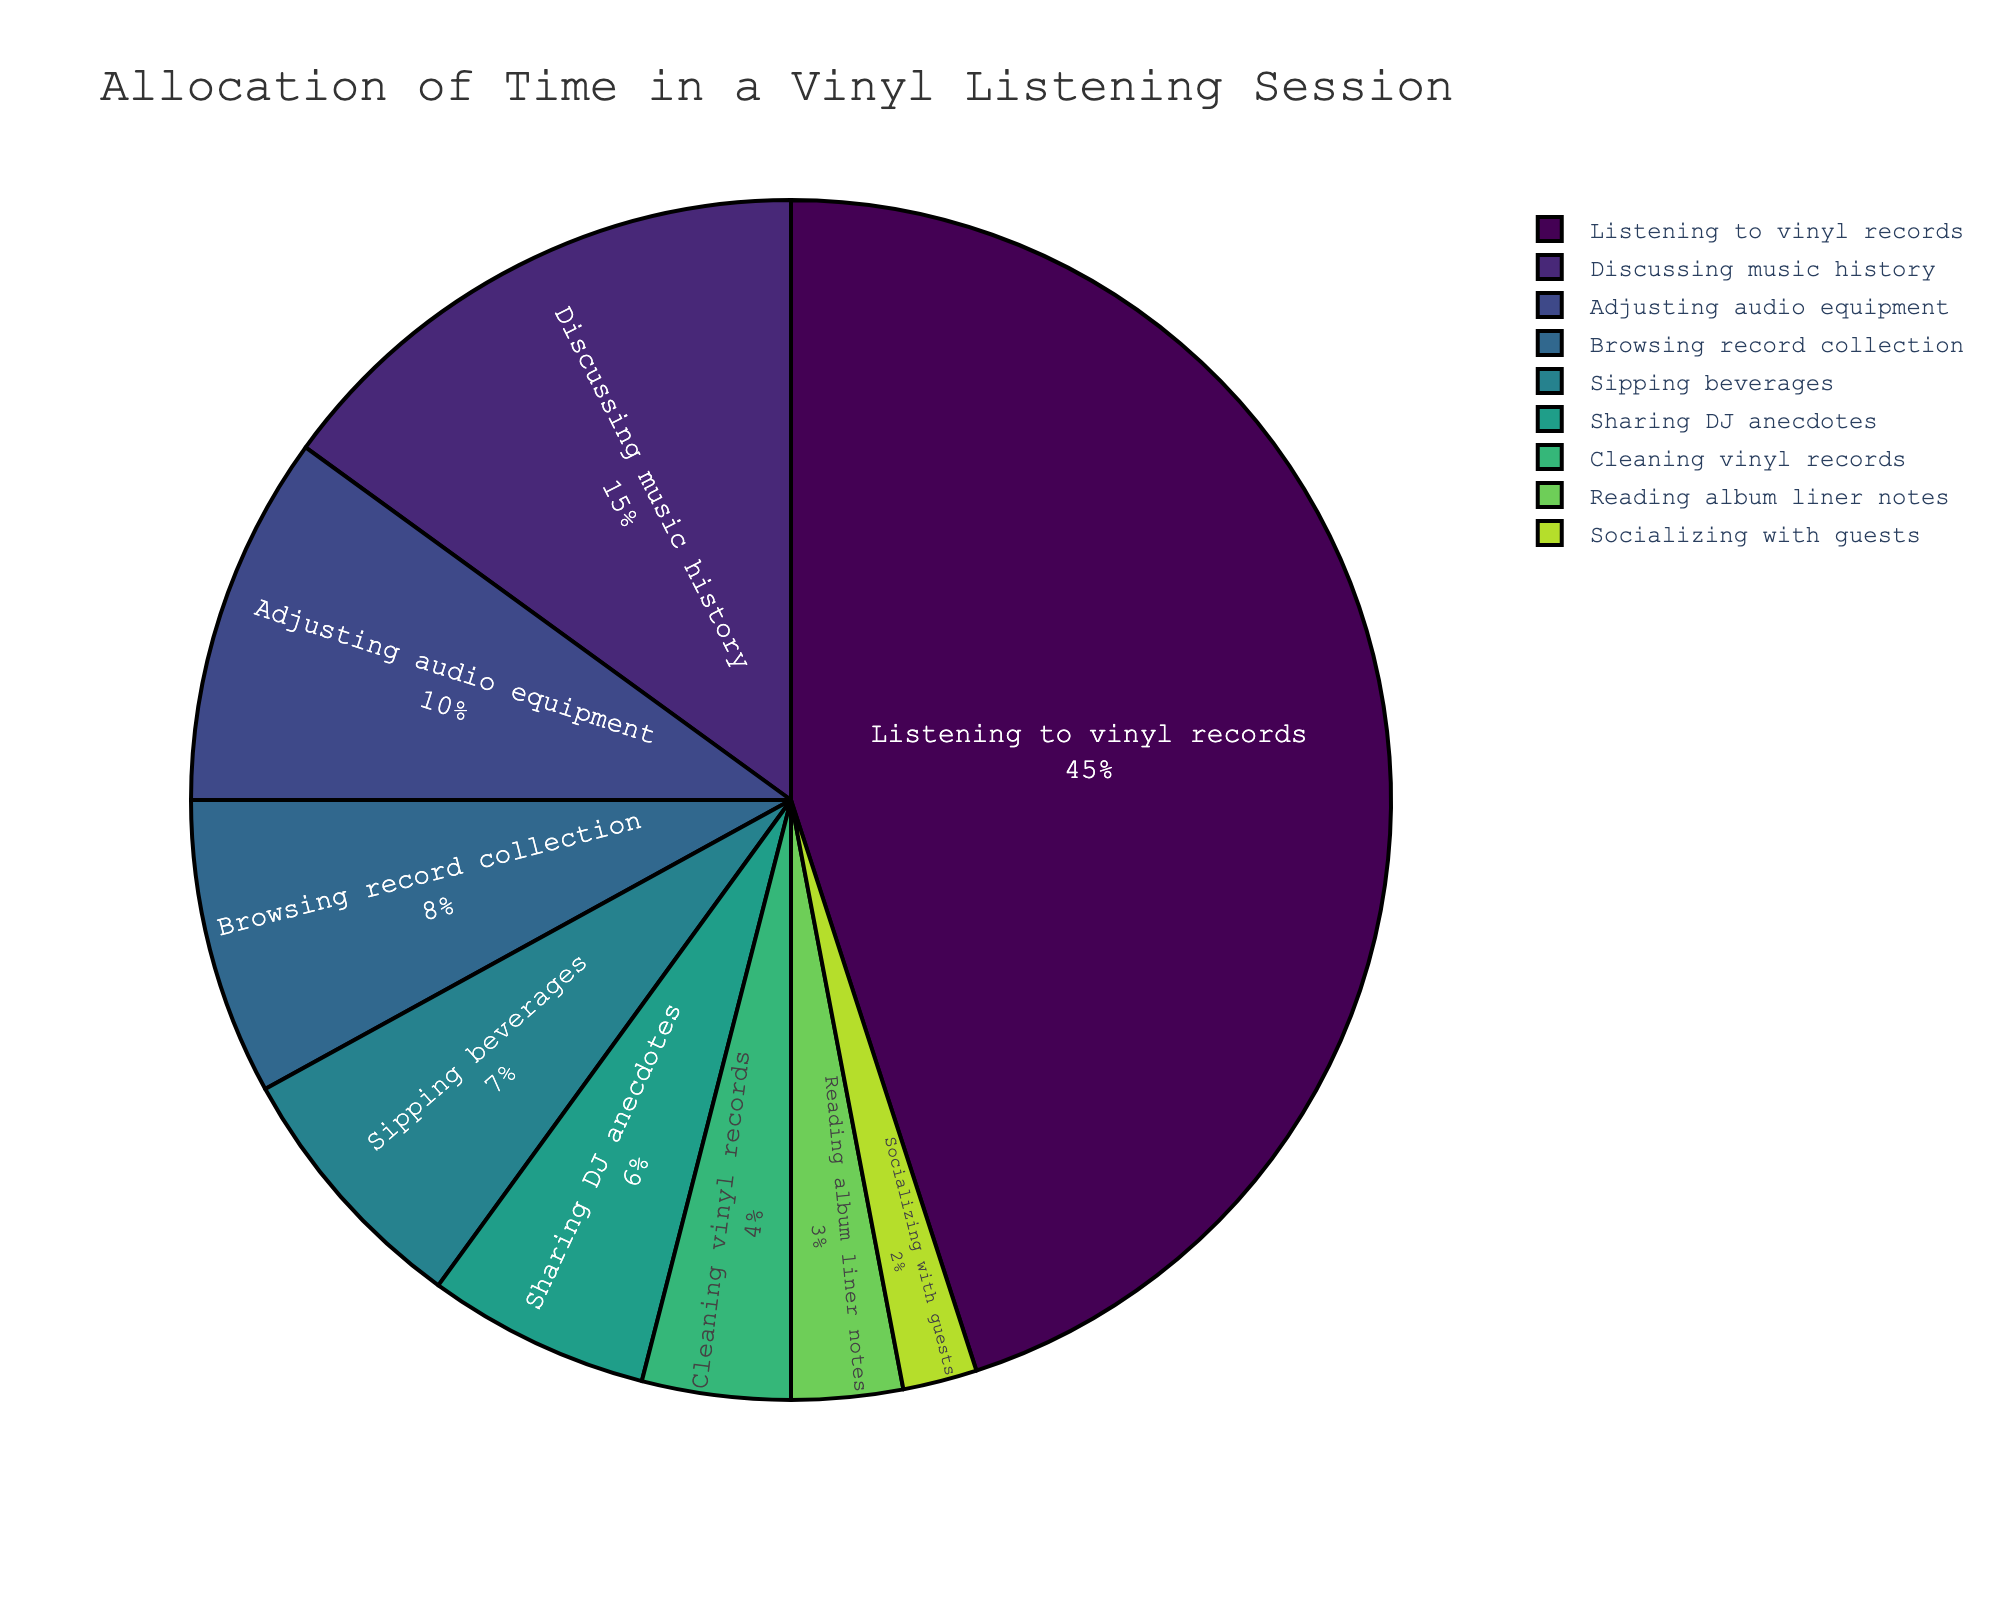Which activity takes up the most time during a vinyl listening session? Looking at the pie chart, the segment for "Listening to vinyl records" is the largest, which indicates it takes up the most time.
Answer: Listening to vinyl records What percentage of time is spent on activities other than listening to vinyl records? To find this, subtract the percentage for "Listening to vinyl records" from 100%. So, 100% - 45% = 55%.
Answer: 55% How much more time is spent discussing music history compared to sipping beverages? The percentage for discussing music history is 15% and sipping beverages is 7%. Subtracting these gives 15% - 7% = 8%.
Answer: 8% Which activity has the smallest allocation of time? Checking the pie chart, the smallest segment is for "Socializing with guests" at 2%.
Answer: Socializing with guests Are more time or less time spent sharing DJ anecdotes compared to cleaning vinyl records? Comparing the percentages, "Sharing DJ anecdotes" takes 6% whereas "Cleaning vinyl records" takes 4%. Hence, more time is spent on sharing DJ anecdotes.
Answer: More time How many activities occupy less than 5% of the time? By looking at the pie chart, count the segments less than 5%. These are: Cleaning vinyl records (4%), Reading album liner notes (3%), and Socializing with guests (2%). There are 3 activities.
Answer: 3 What is the total combined percentage for discussing music history and adjusting audio equipment? Adding the percentages together, 15% + 10% = 25%.
Answer: 25% What is the difference in percentage between browsing the record collection and sipping beverages? The percentage for browsing the record collection is 8% and for sipping beverages is 7%. Subtracting these gives 8% - 7% = 1%.
Answer: 1% Which activity takes up exactly half the time of listening to vinyl records? Half of the percentage for listening to vinyl records (45%) is 22.5%. Upon inspection of the chart, no activity occupies 22.5%. Hence, there is no such activity.
Answer: No activity Do the total percentages of sharing DJ anecdotes and socializing with guests exceed the percentage spent browsing the record collection? The combined percentage for sharing DJ anecdotes (6%) and socializing with guests (2%) is 6% + 2% = 8%. Browsing the record collection occupies 8%, so the totals are equal.
Answer: Equal 